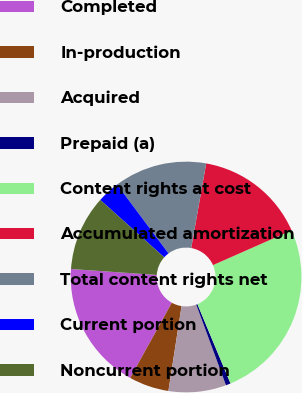Convert chart to OTSL. <chart><loc_0><loc_0><loc_500><loc_500><pie_chart><fcel>Completed<fcel>In-production<fcel>Acquired<fcel>Prepaid (a)<fcel>Content rights at cost<fcel>Accumulated amortization<fcel>Total content rights net<fcel>Current portion<fcel>Noncurrent portion<nl><fcel>18.06%<fcel>5.6%<fcel>8.07%<fcel>0.67%<fcel>25.33%<fcel>15.59%<fcel>13.0%<fcel>3.14%<fcel>10.54%<nl></chart> 